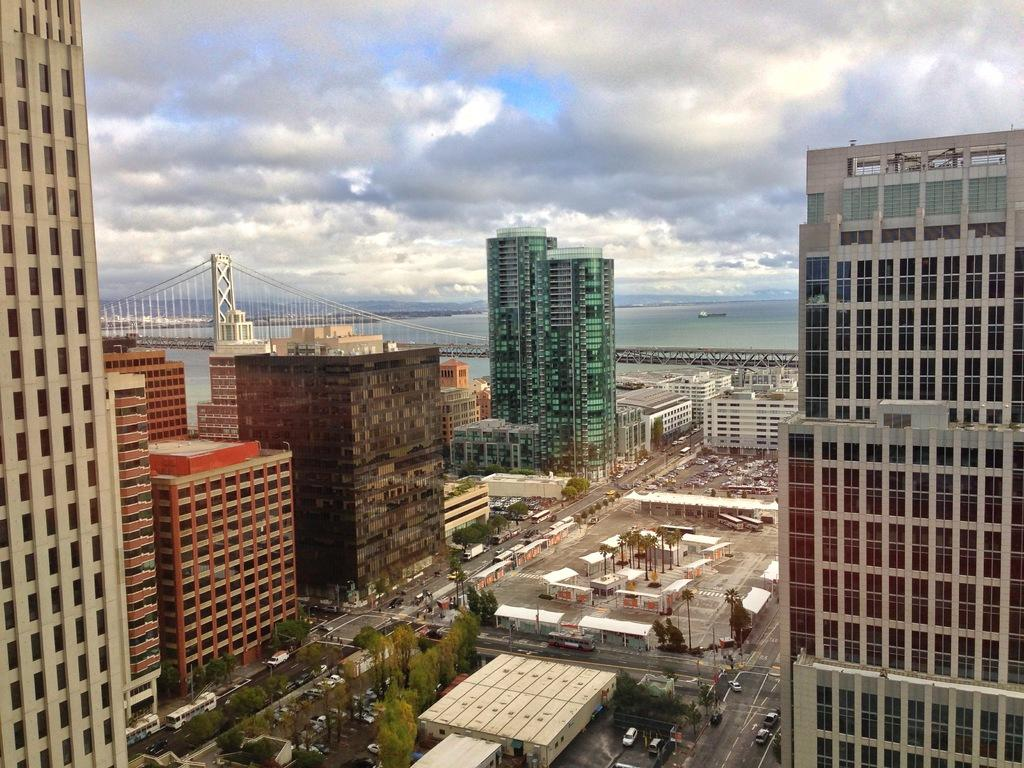What type of structures can be seen in the image? There are buildings in the image. What other natural elements are present in the image? There are trees in the image. What man-made objects can be seen in the image? There are poles in the image. What is happening on the road in the image? There are vehicles on the road in the image. Can you describe the background of the image? In the background, there is a bridge, buildings, water, mountains, and clouds in the sky. Are there any pets visible in the image? There are no pets present in the image. Can you tell me how many people are playing in the lake in the image? There is no lake present in the image, so no one can be playing in it. 